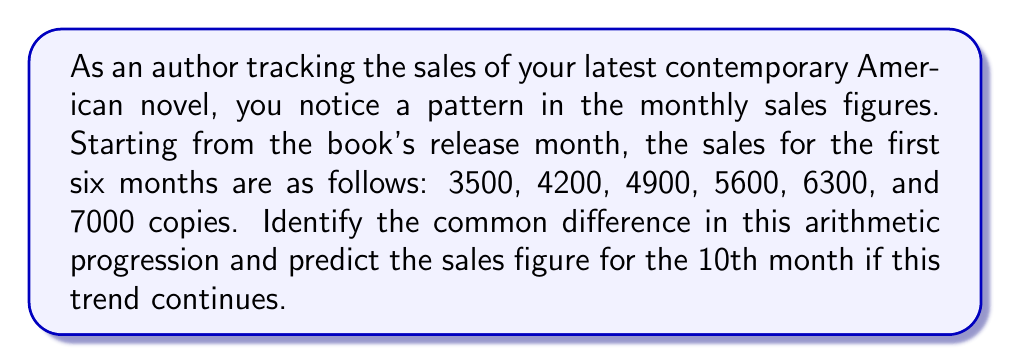Solve this math problem. To solve this problem, let's follow these steps:

1. Confirm that the sequence is an arithmetic progression:
   To do this, we calculate the difference between consecutive terms.
   $4200 - 3500 = 700$
   $4900 - 4200 = 700$
   $5600 - 4900 = 700$
   $6300 - 5600 = 700$
   $7000 - 6300 = 700$

   Since the difference is constant (700), this is indeed an arithmetic progression.

2. Identify the common difference:
   The common difference, d, is 700.

3. Use the arithmetic sequence formula to predict the 10th month's sales:
   The formula for the nth term of an arithmetic sequence is:
   $a_n = a_1 + (n-1)d$

   Where:
   $a_n$ is the nth term
   $a_1$ is the first term (3500 in this case)
   $n$ is the position of the term we're looking for (10 in this case)
   $d$ is the common difference (700)

   Substituting these values:
   $a_{10} = 3500 + (10-1)700$
   $a_{10} = 3500 + 9 * 700$
   $a_{10} = 3500 + 6300$
   $a_{10} = 9800$

Therefore, if the trend continues, the sales figure for the 10th month would be 9800 copies.
Answer: 700; 9800 